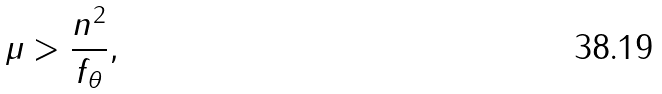<formula> <loc_0><loc_0><loc_500><loc_500>\mu > \frac { n ^ { 2 } } { f _ { \theta } } ,</formula> 